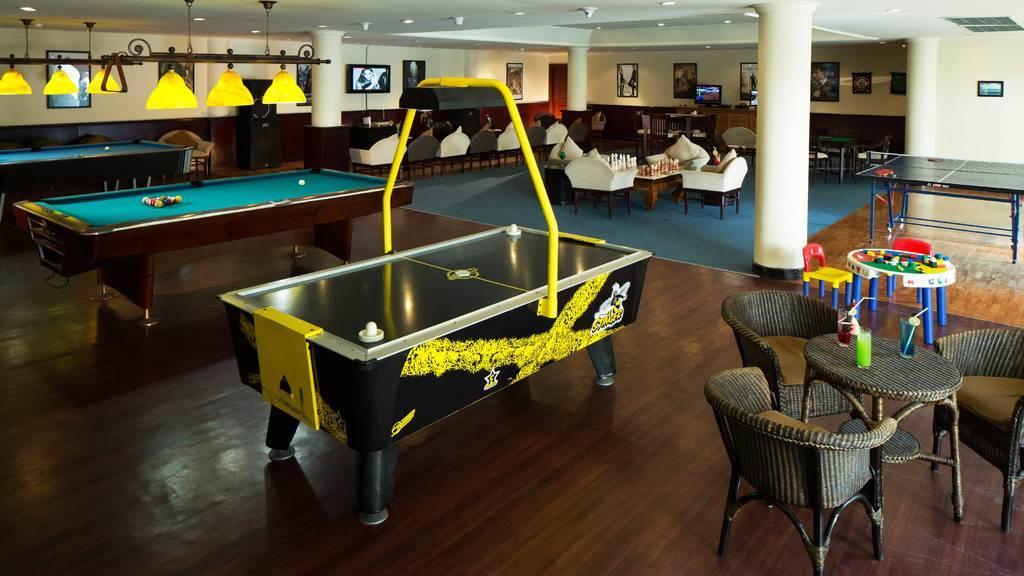Please provide a concise description of this image. This is an inside view. Here I can see some games on the floor. On the the right side there is a table and chairs. In the background I can see some empty chairs and pillars. There are few frames and screens are attached to the wall. It is looking like a playing zone. 